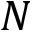Convert formula to latex. <formula><loc_0><loc_0><loc_500><loc_500>N</formula> 